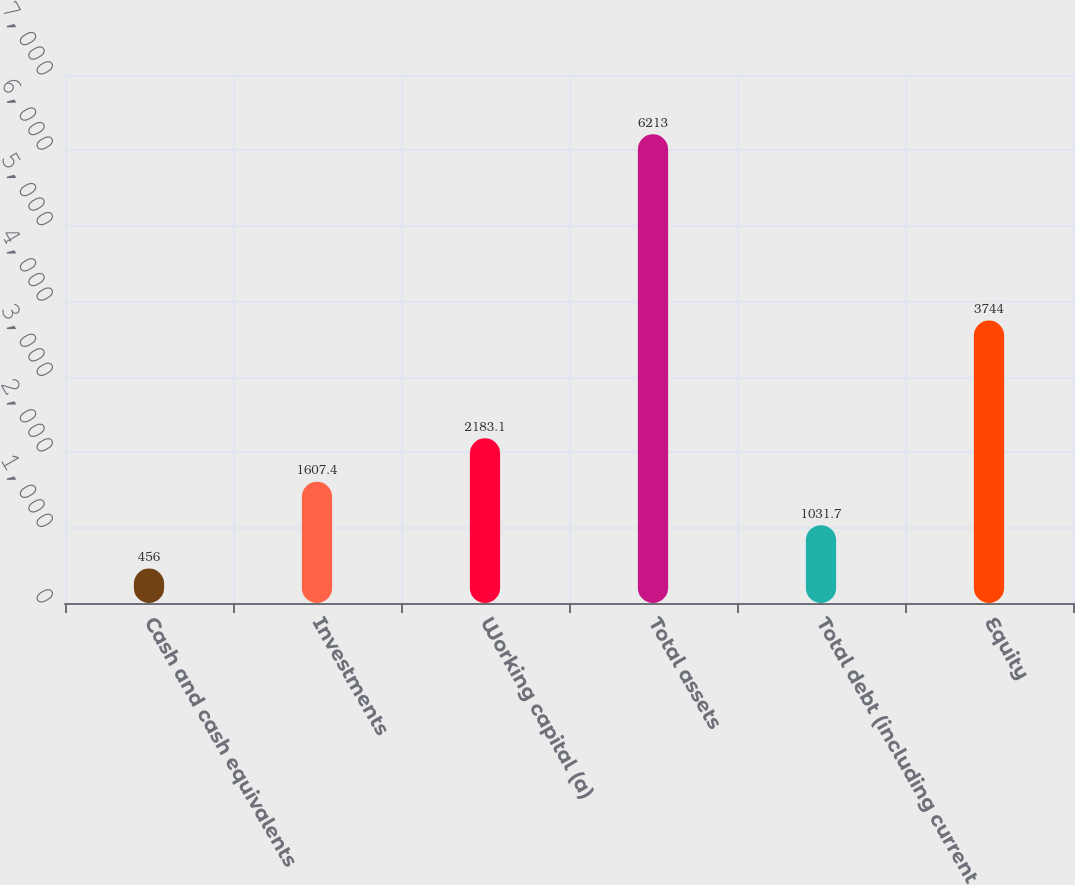Convert chart. <chart><loc_0><loc_0><loc_500><loc_500><bar_chart><fcel>Cash and cash equivalents<fcel>Investments<fcel>Working capital (a)<fcel>Total assets<fcel>Total debt (including current<fcel>Equity<nl><fcel>456<fcel>1607.4<fcel>2183.1<fcel>6213<fcel>1031.7<fcel>3744<nl></chart> 